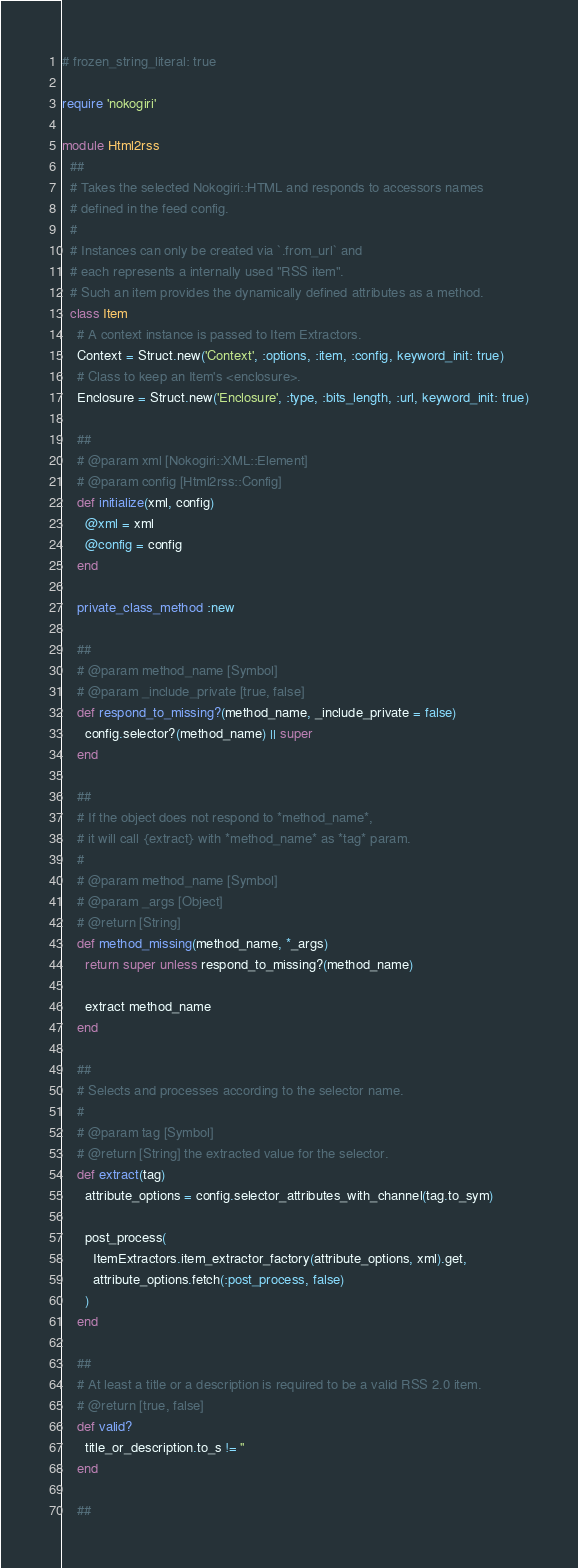Convert code to text. <code><loc_0><loc_0><loc_500><loc_500><_Ruby_># frozen_string_literal: true

require 'nokogiri'

module Html2rss
  ##
  # Takes the selected Nokogiri::HTML and responds to accessors names
  # defined in the feed config.
  #
  # Instances can only be created via `.from_url` and
  # each represents a internally used "RSS item".
  # Such an item provides the dynamically defined attributes as a method.
  class Item
    # A context instance is passed to Item Extractors.
    Context = Struct.new('Context', :options, :item, :config, keyword_init: true)
    # Class to keep an Item's <enclosure>.
    Enclosure = Struct.new('Enclosure', :type, :bits_length, :url, keyword_init: true)

    ##
    # @param xml [Nokogiri::XML::Element]
    # @param config [Html2rss::Config]
    def initialize(xml, config)
      @xml = xml
      @config = config
    end

    private_class_method :new

    ##
    # @param method_name [Symbol]
    # @param _include_private [true, false]
    def respond_to_missing?(method_name, _include_private = false)
      config.selector?(method_name) || super
    end

    ##
    # If the object does not respond to *method_name*,
    # it will call {extract} with *method_name* as *tag* param.
    #
    # @param method_name [Symbol]
    # @param _args [Object]
    # @return [String]
    def method_missing(method_name, *_args)
      return super unless respond_to_missing?(method_name)

      extract method_name
    end

    ##
    # Selects and processes according to the selector name.
    #
    # @param tag [Symbol]
    # @return [String] the extracted value for the selector.
    def extract(tag)
      attribute_options = config.selector_attributes_with_channel(tag.to_sym)

      post_process(
        ItemExtractors.item_extractor_factory(attribute_options, xml).get,
        attribute_options.fetch(:post_process, false)
      )
    end

    ##
    # At least a title or a description is required to be a valid RSS 2.0 item.
    # @return [true, false]
    def valid?
      title_or_description.to_s != ''
    end

    ##</code> 